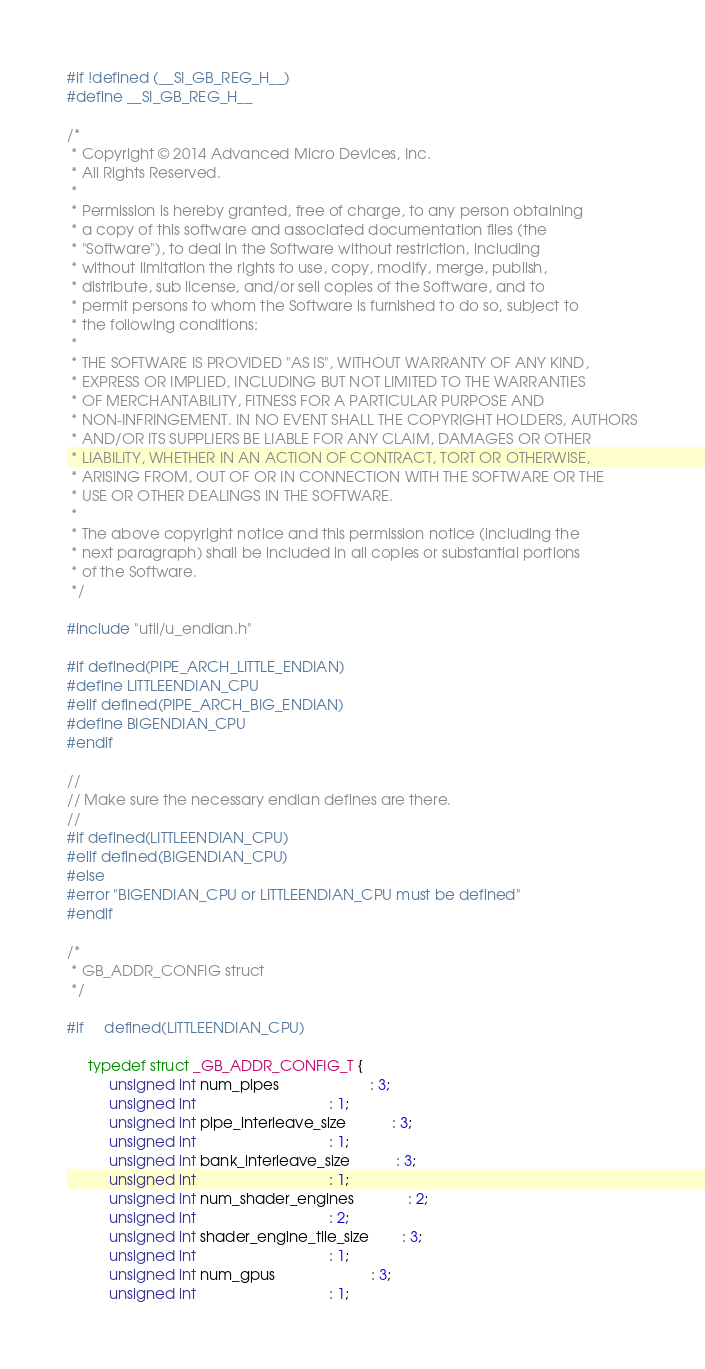<code> <loc_0><loc_0><loc_500><loc_500><_C_>#if !defined (__SI_GB_REG_H__)
#define __SI_GB_REG_H__

/*
 * Copyright © 2014 Advanced Micro Devices, Inc.
 * All Rights Reserved.
 *
 * Permission is hereby granted, free of charge, to any person obtaining
 * a copy of this software and associated documentation files (the
 * "Software"), to deal in the Software without restriction, including
 * without limitation the rights to use, copy, modify, merge, publish,
 * distribute, sub license, and/or sell copies of the Software, and to
 * permit persons to whom the Software is furnished to do so, subject to
 * the following conditions:
 *
 * THE SOFTWARE IS PROVIDED "AS IS", WITHOUT WARRANTY OF ANY KIND,
 * EXPRESS OR IMPLIED, INCLUDING BUT NOT LIMITED TO THE WARRANTIES
 * OF MERCHANTABILITY, FITNESS FOR A PARTICULAR PURPOSE AND
 * NON-INFRINGEMENT. IN NO EVENT SHALL THE COPYRIGHT HOLDERS, AUTHORS
 * AND/OR ITS SUPPLIERS BE LIABLE FOR ANY CLAIM, DAMAGES OR OTHER
 * LIABILITY, WHETHER IN AN ACTION OF CONTRACT, TORT OR OTHERWISE,
 * ARISING FROM, OUT OF OR IN CONNECTION WITH THE SOFTWARE OR THE
 * USE OR OTHER DEALINGS IN THE SOFTWARE.
 *
 * The above copyright notice and this permission notice (including the
 * next paragraph) shall be included in all copies or substantial portions
 * of the Software.
 */

#include "util/u_endian.h"

#if defined(PIPE_ARCH_LITTLE_ENDIAN)
#define LITTLEENDIAN_CPU
#elif defined(PIPE_ARCH_BIG_ENDIAN)
#define BIGENDIAN_CPU
#endif

//
// Make sure the necessary endian defines are there.
//
#if defined(LITTLEENDIAN_CPU)
#elif defined(BIGENDIAN_CPU)
#else
#error "BIGENDIAN_CPU or LITTLEENDIAN_CPU must be defined"
#endif

/*
 * GB_ADDR_CONFIG struct
 */

#if     defined(LITTLEENDIAN_CPU)

     typedef struct _GB_ADDR_CONFIG_T {
          unsigned int num_pipes                      : 3;
          unsigned int                                : 1;
          unsigned int pipe_interleave_size           : 3;
          unsigned int                                : 1;
          unsigned int bank_interleave_size           : 3;
          unsigned int                                : 1;
          unsigned int num_shader_engines             : 2;
          unsigned int                                : 2;
          unsigned int shader_engine_tile_size        : 3;
          unsigned int                                : 1;
          unsigned int num_gpus                       : 3;
          unsigned int                                : 1;</code> 